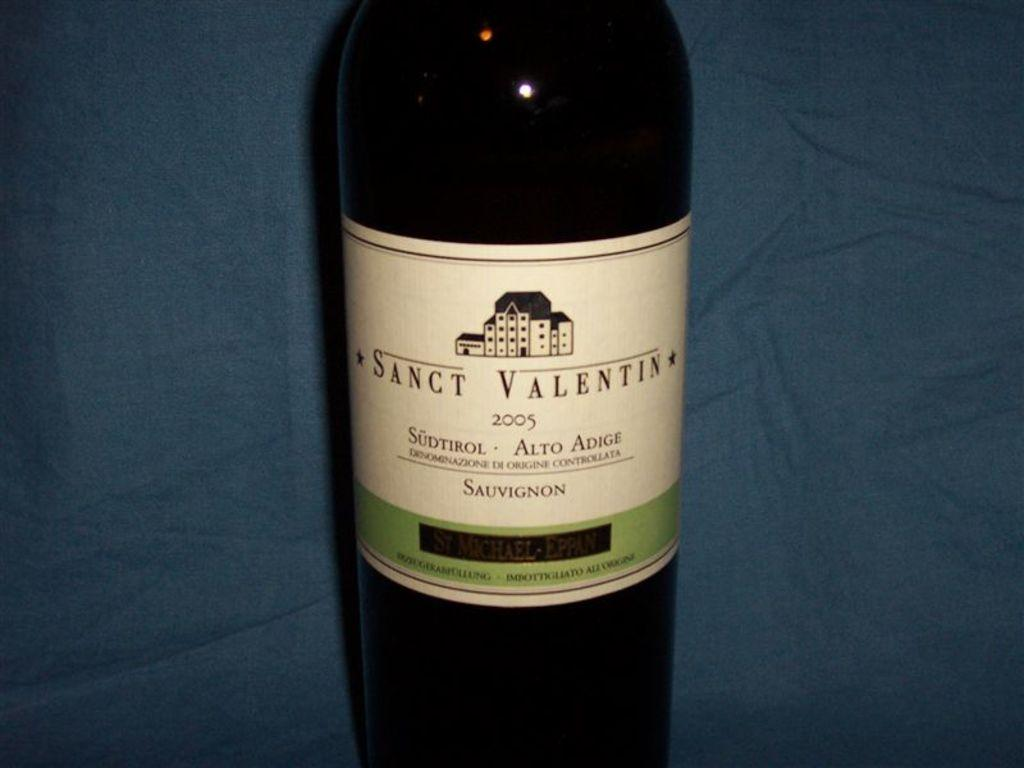<image>
Write a terse but informative summary of the picture. the word sanct that is on a wine bottle 